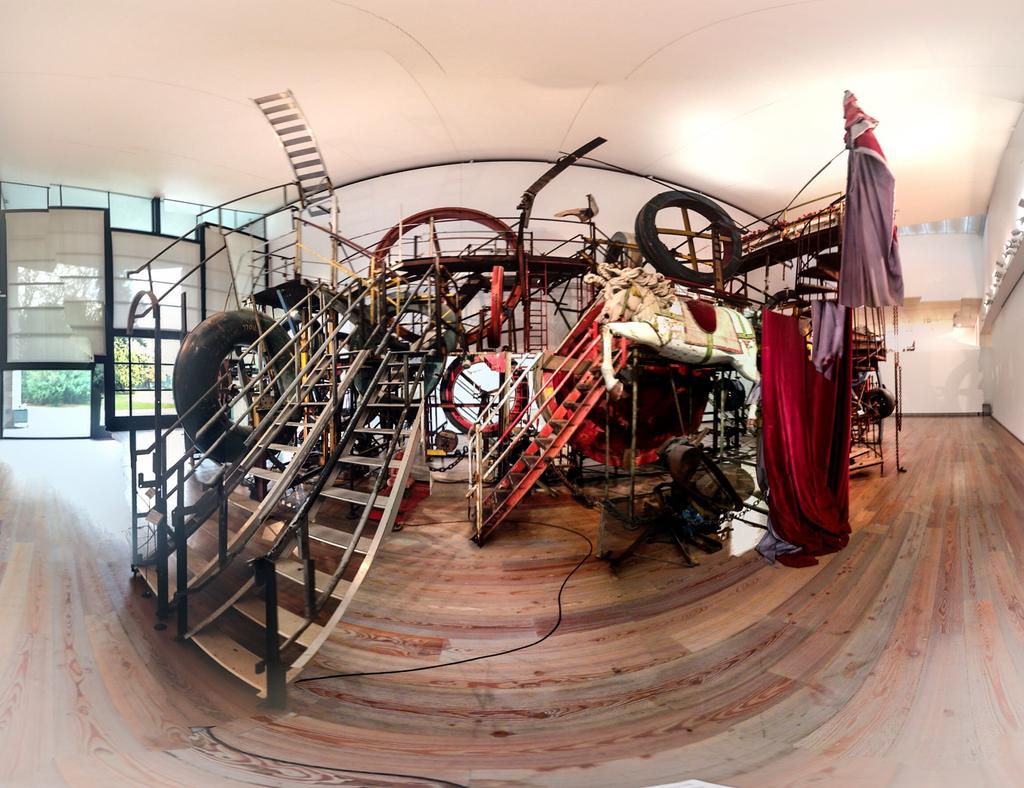What type of vegetation can be seen in the image? There are trees in the image. What else can be seen in the image besides trees? There are clothes and stairs visible in the image. Are there any other objects present in the image? Yes, there are other objects in the image. What can be seen in the background of the image? There are plants in the background of the image. What type of bun is being used to hold the clothes in the image? There is no bun present in the image; the clothes are not being held by any bun. 